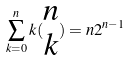<formula> <loc_0><loc_0><loc_500><loc_500>\sum _ { k = 0 } ^ { n } k ( \begin{matrix} n \\ k \end{matrix} ) = n 2 ^ { n - 1 }</formula> 